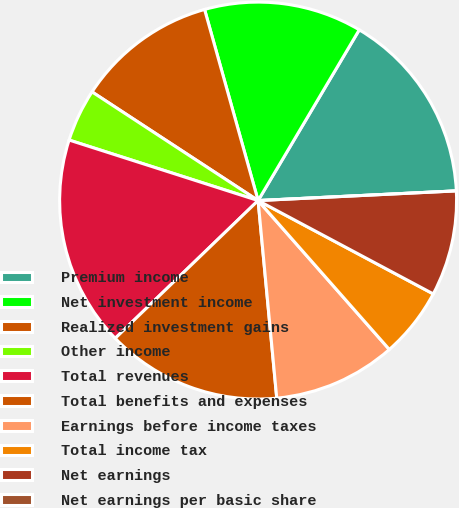<chart> <loc_0><loc_0><loc_500><loc_500><pie_chart><fcel>Premium income<fcel>Net investment income<fcel>Realized investment gains<fcel>Other income<fcel>Total revenues<fcel>Total benefits and expenses<fcel>Earnings before income taxes<fcel>Total income tax<fcel>Net earnings<fcel>Net earnings per basic share<nl><fcel>15.71%<fcel>12.86%<fcel>11.43%<fcel>4.29%<fcel>17.14%<fcel>14.29%<fcel>10.0%<fcel>5.71%<fcel>8.57%<fcel>0.0%<nl></chart> 